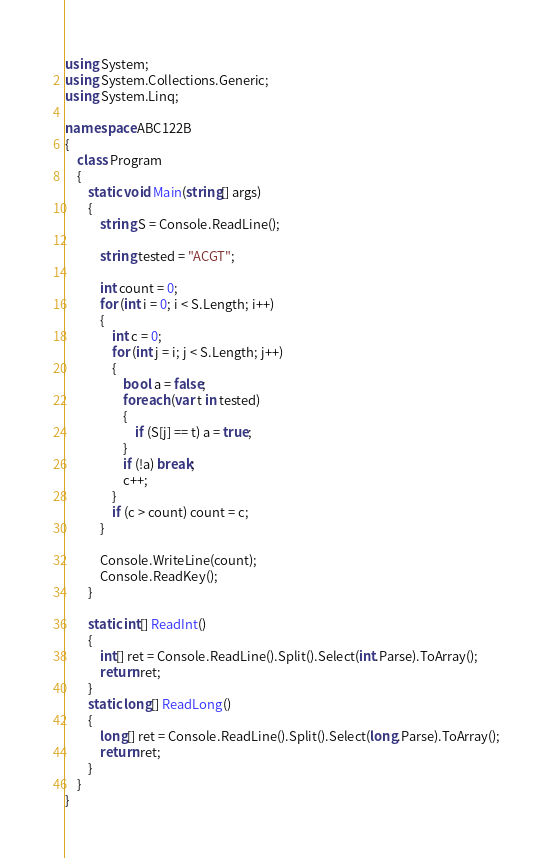Convert code to text. <code><loc_0><loc_0><loc_500><loc_500><_C#_>using System;
using System.Collections.Generic;
using System.Linq;

namespace ABC122B
{
    class Program
    {
        static void Main(string[] args)
        {
            string S = Console.ReadLine();

            string tested = "ACGT";

            int count = 0;
            for (int i = 0; i < S.Length; i++)
            {
                int c = 0;
                for (int j = i; j < S.Length; j++)
                {
                    bool a = false;
                    foreach (var t in tested)
                    {
                        if (S[j] == t) a = true;
                    }
                    if (!a) break;
                    c++;
                }
                if (c > count) count = c;
            }

            Console.WriteLine(count);
            Console.ReadKey();
        }

        static int[] ReadInt()
        {
            int[] ret = Console.ReadLine().Split().Select(int.Parse).ToArray();
            return ret;
        }
        static long[] ReadLong()
        {
            long[] ret = Console.ReadLine().Split().Select(long.Parse).ToArray();
            return ret;
        }
    }
}
</code> 